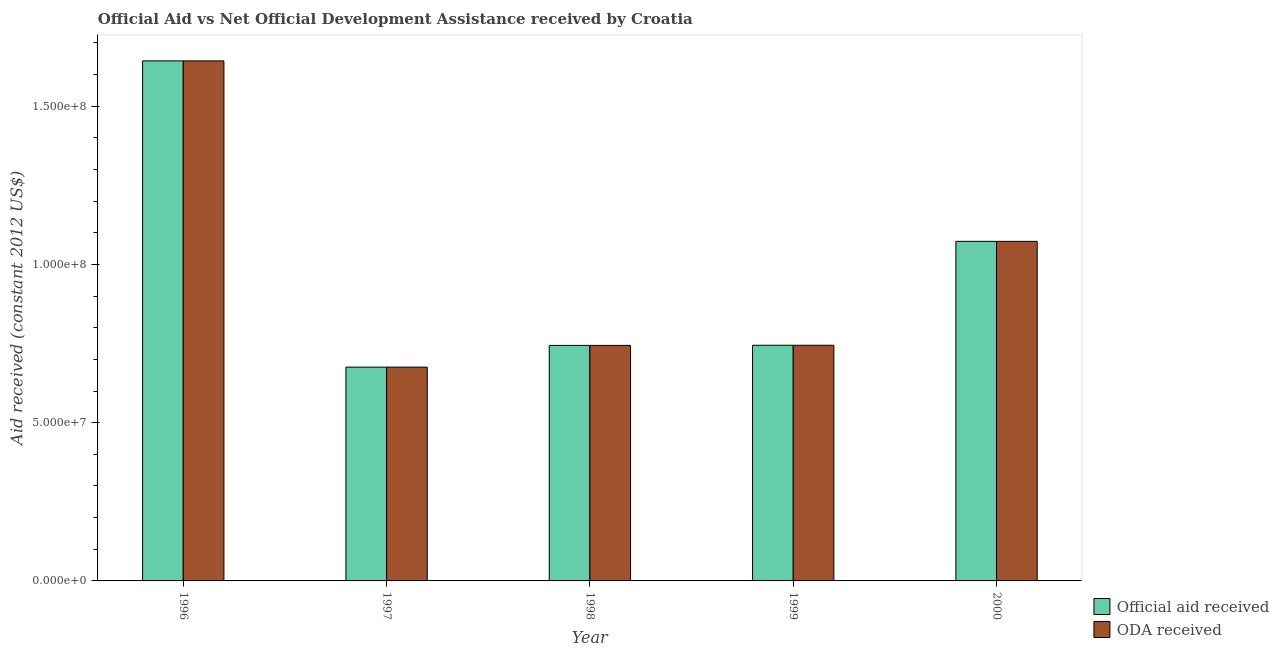Are the number of bars on each tick of the X-axis equal?
Make the answer very short. Yes. How many bars are there on the 3rd tick from the right?
Your response must be concise. 2. What is the label of the 1st group of bars from the left?
Make the answer very short. 1996. What is the official aid received in 1997?
Your response must be concise. 6.76e+07. Across all years, what is the maximum oda received?
Your answer should be compact. 1.64e+08. Across all years, what is the minimum official aid received?
Keep it short and to the point. 6.76e+07. In which year was the oda received maximum?
Your response must be concise. 1996. In which year was the official aid received minimum?
Give a very brief answer. 1997. What is the total oda received in the graph?
Offer a terse response. 4.88e+08. What is the difference between the official aid received in 1996 and that in 1997?
Your response must be concise. 9.68e+07. What is the difference between the oda received in 1996 and the official aid received in 1997?
Provide a short and direct response. 9.68e+07. What is the average official aid received per year?
Provide a succinct answer. 9.76e+07. In the year 1996, what is the difference between the official aid received and oda received?
Provide a succinct answer. 0. What is the ratio of the official aid received in 1996 to that in 2000?
Your response must be concise. 1.53. Is the oda received in 1997 less than that in 1998?
Your response must be concise. Yes. Is the difference between the oda received in 1996 and 1997 greater than the difference between the official aid received in 1996 and 1997?
Your response must be concise. No. What is the difference between the highest and the second highest oda received?
Provide a short and direct response. 5.70e+07. What is the difference between the highest and the lowest official aid received?
Your response must be concise. 9.68e+07. In how many years, is the oda received greater than the average oda received taken over all years?
Provide a succinct answer. 2. Is the sum of the oda received in 1996 and 1998 greater than the maximum official aid received across all years?
Provide a succinct answer. Yes. What does the 1st bar from the left in 2000 represents?
Your response must be concise. Official aid received. What does the 2nd bar from the right in 1997 represents?
Offer a very short reply. Official aid received. How many bars are there?
Offer a very short reply. 10. What is the difference between two consecutive major ticks on the Y-axis?
Provide a short and direct response. 5.00e+07. Does the graph contain any zero values?
Offer a terse response. No. Does the graph contain grids?
Provide a succinct answer. No. Where does the legend appear in the graph?
Your answer should be compact. Bottom right. How many legend labels are there?
Keep it short and to the point. 2. How are the legend labels stacked?
Provide a succinct answer. Vertical. What is the title of the graph?
Your answer should be compact. Official Aid vs Net Official Development Assistance received by Croatia . What is the label or title of the Y-axis?
Give a very brief answer. Aid received (constant 2012 US$). What is the Aid received (constant 2012 US$) in Official aid received in 1996?
Give a very brief answer. 1.64e+08. What is the Aid received (constant 2012 US$) of ODA received in 1996?
Ensure brevity in your answer.  1.64e+08. What is the Aid received (constant 2012 US$) in Official aid received in 1997?
Keep it short and to the point. 6.76e+07. What is the Aid received (constant 2012 US$) of ODA received in 1997?
Keep it short and to the point. 6.76e+07. What is the Aid received (constant 2012 US$) in Official aid received in 1998?
Your answer should be compact. 7.44e+07. What is the Aid received (constant 2012 US$) in ODA received in 1998?
Keep it short and to the point. 7.44e+07. What is the Aid received (constant 2012 US$) of Official aid received in 1999?
Ensure brevity in your answer.  7.45e+07. What is the Aid received (constant 2012 US$) in ODA received in 1999?
Provide a succinct answer. 7.45e+07. What is the Aid received (constant 2012 US$) of Official aid received in 2000?
Your answer should be compact. 1.07e+08. What is the Aid received (constant 2012 US$) in ODA received in 2000?
Ensure brevity in your answer.  1.07e+08. Across all years, what is the maximum Aid received (constant 2012 US$) in Official aid received?
Make the answer very short. 1.64e+08. Across all years, what is the maximum Aid received (constant 2012 US$) of ODA received?
Provide a succinct answer. 1.64e+08. Across all years, what is the minimum Aid received (constant 2012 US$) of Official aid received?
Give a very brief answer. 6.76e+07. Across all years, what is the minimum Aid received (constant 2012 US$) in ODA received?
Offer a terse response. 6.76e+07. What is the total Aid received (constant 2012 US$) of Official aid received in the graph?
Ensure brevity in your answer.  4.88e+08. What is the total Aid received (constant 2012 US$) of ODA received in the graph?
Offer a terse response. 4.88e+08. What is the difference between the Aid received (constant 2012 US$) in Official aid received in 1996 and that in 1997?
Keep it short and to the point. 9.68e+07. What is the difference between the Aid received (constant 2012 US$) of ODA received in 1996 and that in 1997?
Offer a very short reply. 9.68e+07. What is the difference between the Aid received (constant 2012 US$) in Official aid received in 1996 and that in 1998?
Your answer should be very brief. 8.99e+07. What is the difference between the Aid received (constant 2012 US$) in ODA received in 1996 and that in 1998?
Provide a short and direct response. 8.99e+07. What is the difference between the Aid received (constant 2012 US$) of Official aid received in 1996 and that in 1999?
Offer a terse response. 8.99e+07. What is the difference between the Aid received (constant 2012 US$) of ODA received in 1996 and that in 1999?
Your response must be concise. 8.99e+07. What is the difference between the Aid received (constant 2012 US$) of Official aid received in 1996 and that in 2000?
Make the answer very short. 5.70e+07. What is the difference between the Aid received (constant 2012 US$) of ODA received in 1996 and that in 2000?
Give a very brief answer. 5.70e+07. What is the difference between the Aid received (constant 2012 US$) of Official aid received in 1997 and that in 1998?
Provide a short and direct response. -6.87e+06. What is the difference between the Aid received (constant 2012 US$) in ODA received in 1997 and that in 1998?
Your answer should be very brief. -6.87e+06. What is the difference between the Aid received (constant 2012 US$) of Official aid received in 1997 and that in 1999?
Give a very brief answer. -6.91e+06. What is the difference between the Aid received (constant 2012 US$) in ODA received in 1997 and that in 1999?
Your response must be concise. -6.91e+06. What is the difference between the Aid received (constant 2012 US$) of Official aid received in 1997 and that in 2000?
Offer a terse response. -3.98e+07. What is the difference between the Aid received (constant 2012 US$) in ODA received in 1997 and that in 2000?
Your response must be concise. -3.98e+07. What is the difference between the Aid received (constant 2012 US$) of Official aid received in 1998 and that in 1999?
Ensure brevity in your answer.  -4.00e+04. What is the difference between the Aid received (constant 2012 US$) in ODA received in 1998 and that in 1999?
Offer a very short reply. -4.00e+04. What is the difference between the Aid received (constant 2012 US$) in Official aid received in 1998 and that in 2000?
Offer a terse response. -3.29e+07. What is the difference between the Aid received (constant 2012 US$) of ODA received in 1998 and that in 2000?
Make the answer very short. -3.29e+07. What is the difference between the Aid received (constant 2012 US$) in Official aid received in 1999 and that in 2000?
Offer a terse response. -3.28e+07. What is the difference between the Aid received (constant 2012 US$) of ODA received in 1999 and that in 2000?
Provide a succinct answer. -3.28e+07. What is the difference between the Aid received (constant 2012 US$) in Official aid received in 1996 and the Aid received (constant 2012 US$) in ODA received in 1997?
Make the answer very short. 9.68e+07. What is the difference between the Aid received (constant 2012 US$) of Official aid received in 1996 and the Aid received (constant 2012 US$) of ODA received in 1998?
Ensure brevity in your answer.  8.99e+07. What is the difference between the Aid received (constant 2012 US$) of Official aid received in 1996 and the Aid received (constant 2012 US$) of ODA received in 1999?
Your response must be concise. 8.99e+07. What is the difference between the Aid received (constant 2012 US$) of Official aid received in 1996 and the Aid received (constant 2012 US$) of ODA received in 2000?
Your answer should be very brief. 5.70e+07. What is the difference between the Aid received (constant 2012 US$) in Official aid received in 1997 and the Aid received (constant 2012 US$) in ODA received in 1998?
Provide a short and direct response. -6.87e+06. What is the difference between the Aid received (constant 2012 US$) of Official aid received in 1997 and the Aid received (constant 2012 US$) of ODA received in 1999?
Provide a short and direct response. -6.91e+06. What is the difference between the Aid received (constant 2012 US$) of Official aid received in 1997 and the Aid received (constant 2012 US$) of ODA received in 2000?
Keep it short and to the point. -3.98e+07. What is the difference between the Aid received (constant 2012 US$) in Official aid received in 1998 and the Aid received (constant 2012 US$) in ODA received in 2000?
Offer a very short reply. -3.29e+07. What is the difference between the Aid received (constant 2012 US$) in Official aid received in 1999 and the Aid received (constant 2012 US$) in ODA received in 2000?
Your answer should be compact. -3.28e+07. What is the average Aid received (constant 2012 US$) in Official aid received per year?
Your answer should be compact. 9.76e+07. What is the average Aid received (constant 2012 US$) in ODA received per year?
Give a very brief answer. 9.76e+07. In the year 1997, what is the difference between the Aid received (constant 2012 US$) of Official aid received and Aid received (constant 2012 US$) of ODA received?
Provide a succinct answer. 0. In the year 1999, what is the difference between the Aid received (constant 2012 US$) of Official aid received and Aid received (constant 2012 US$) of ODA received?
Give a very brief answer. 0. In the year 2000, what is the difference between the Aid received (constant 2012 US$) of Official aid received and Aid received (constant 2012 US$) of ODA received?
Offer a very short reply. 0. What is the ratio of the Aid received (constant 2012 US$) in Official aid received in 1996 to that in 1997?
Give a very brief answer. 2.43. What is the ratio of the Aid received (constant 2012 US$) in ODA received in 1996 to that in 1997?
Provide a succinct answer. 2.43. What is the ratio of the Aid received (constant 2012 US$) in Official aid received in 1996 to that in 1998?
Provide a short and direct response. 2.21. What is the ratio of the Aid received (constant 2012 US$) of ODA received in 1996 to that in 1998?
Provide a succinct answer. 2.21. What is the ratio of the Aid received (constant 2012 US$) of Official aid received in 1996 to that in 1999?
Provide a succinct answer. 2.21. What is the ratio of the Aid received (constant 2012 US$) in ODA received in 1996 to that in 1999?
Your answer should be compact. 2.21. What is the ratio of the Aid received (constant 2012 US$) of Official aid received in 1996 to that in 2000?
Ensure brevity in your answer.  1.53. What is the ratio of the Aid received (constant 2012 US$) in ODA received in 1996 to that in 2000?
Provide a short and direct response. 1.53. What is the ratio of the Aid received (constant 2012 US$) of Official aid received in 1997 to that in 1998?
Make the answer very short. 0.91. What is the ratio of the Aid received (constant 2012 US$) of ODA received in 1997 to that in 1998?
Ensure brevity in your answer.  0.91. What is the ratio of the Aid received (constant 2012 US$) in Official aid received in 1997 to that in 1999?
Provide a short and direct response. 0.91. What is the ratio of the Aid received (constant 2012 US$) of ODA received in 1997 to that in 1999?
Your answer should be compact. 0.91. What is the ratio of the Aid received (constant 2012 US$) in Official aid received in 1997 to that in 2000?
Ensure brevity in your answer.  0.63. What is the ratio of the Aid received (constant 2012 US$) in ODA received in 1997 to that in 2000?
Give a very brief answer. 0.63. What is the ratio of the Aid received (constant 2012 US$) in Official aid received in 1998 to that in 1999?
Provide a short and direct response. 1. What is the ratio of the Aid received (constant 2012 US$) of Official aid received in 1998 to that in 2000?
Keep it short and to the point. 0.69. What is the ratio of the Aid received (constant 2012 US$) of ODA received in 1998 to that in 2000?
Your response must be concise. 0.69. What is the ratio of the Aid received (constant 2012 US$) of Official aid received in 1999 to that in 2000?
Your answer should be compact. 0.69. What is the ratio of the Aid received (constant 2012 US$) in ODA received in 1999 to that in 2000?
Your response must be concise. 0.69. What is the difference between the highest and the second highest Aid received (constant 2012 US$) of Official aid received?
Offer a terse response. 5.70e+07. What is the difference between the highest and the second highest Aid received (constant 2012 US$) in ODA received?
Provide a short and direct response. 5.70e+07. What is the difference between the highest and the lowest Aid received (constant 2012 US$) of Official aid received?
Provide a short and direct response. 9.68e+07. What is the difference between the highest and the lowest Aid received (constant 2012 US$) of ODA received?
Your answer should be very brief. 9.68e+07. 